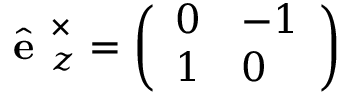<formula> <loc_0><loc_0><loc_500><loc_500>\hat { e } _ { z } ^ { \times } = \left ( \begin{array} { l l } { 0 } & { - 1 } \\ { 1 } & { 0 } \end{array} \right )</formula> 